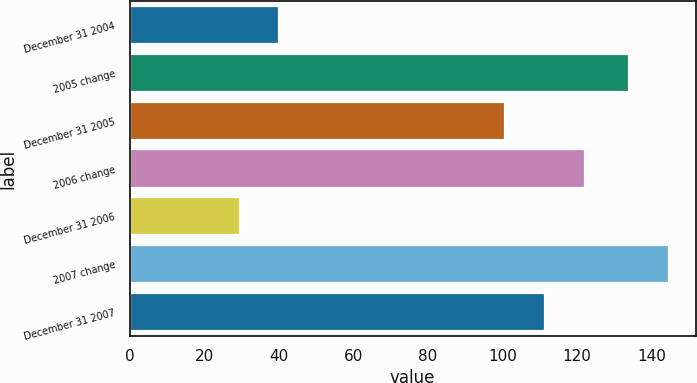Convert chart to OTSL. <chart><loc_0><loc_0><loc_500><loc_500><bar_chart><fcel>December 31 2004<fcel>2005 change<fcel>December 31 2005<fcel>2006 change<fcel>December 31 2006<fcel>2007 change<fcel>December 31 2007<nl><fcel>40.19<fcel>133.9<fcel>100.7<fcel>122.08<fcel>29.5<fcel>144.59<fcel>111.39<nl></chart> 